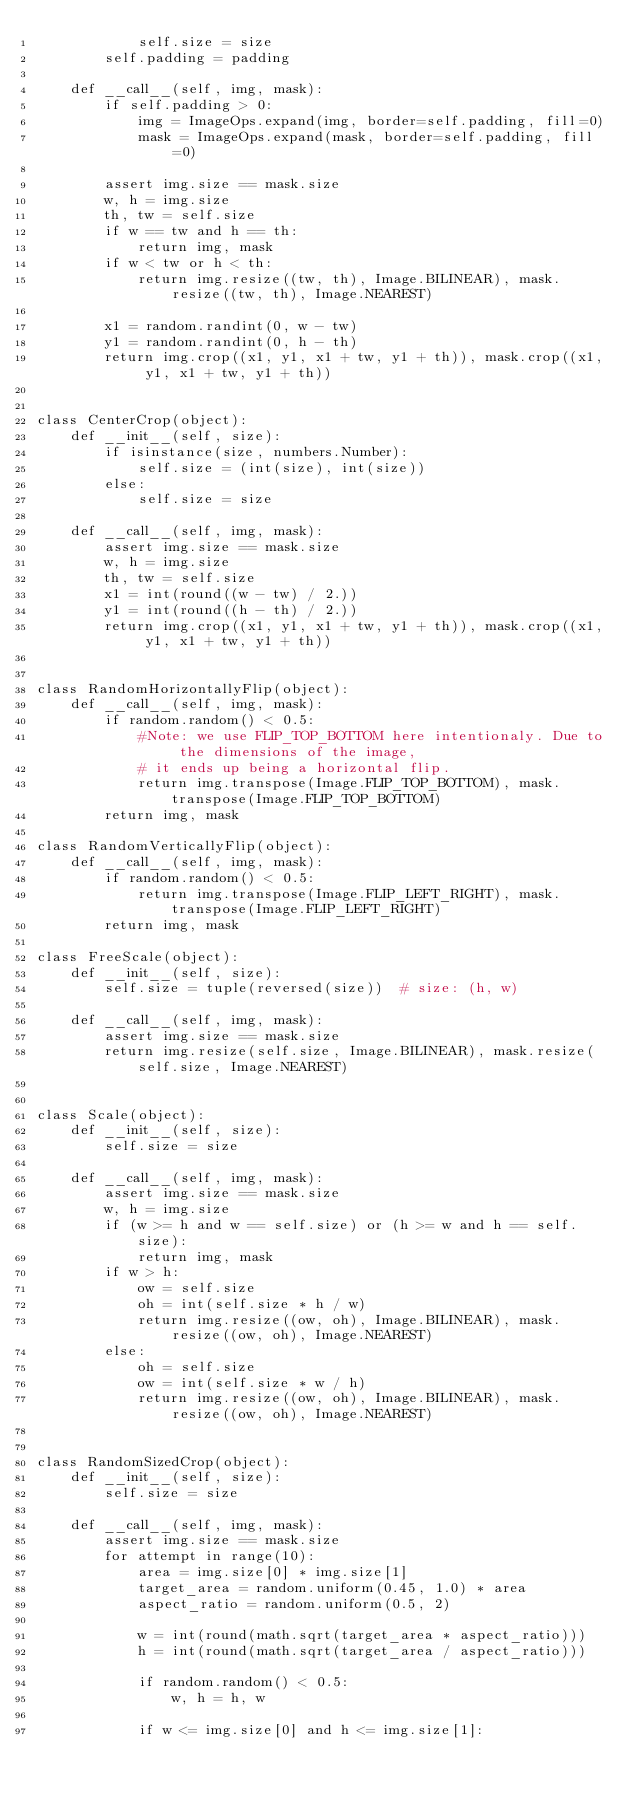Convert code to text. <code><loc_0><loc_0><loc_500><loc_500><_Python_>            self.size = size
        self.padding = padding

    def __call__(self, img, mask):
        if self.padding > 0:
            img = ImageOps.expand(img, border=self.padding, fill=0)
            mask = ImageOps.expand(mask, border=self.padding, fill=0)

        assert img.size == mask.size
        w, h = img.size
        th, tw = self.size
        if w == tw and h == th:
            return img, mask
        if w < tw or h < th:
            return img.resize((tw, th), Image.BILINEAR), mask.resize((tw, th), Image.NEAREST)

        x1 = random.randint(0, w - tw)
        y1 = random.randint(0, h - th)
        return img.crop((x1, y1, x1 + tw, y1 + th)), mask.crop((x1, y1, x1 + tw, y1 + th))


class CenterCrop(object):
    def __init__(self, size):
        if isinstance(size, numbers.Number):
            self.size = (int(size), int(size))
        else:
            self.size = size

    def __call__(self, img, mask):
        assert img.size == mask.size
        w, h = img.size
        th, tw = self.size
        x1 = int(round((w - tw) / 2.))
        y1 = int(round((h - th) / 2.))
        return img.crop((x1, y1, x1 + tw, y1 + th)), mask.crop((x1, y1, x1 + tw, y1 + th))


class RandomHorizontallyFlip(object):
    def __call__(self, img, mask):
        if random.random() < 0.5:
            #Note: we use FLIP_TOP_BOTTOM here intentionaly. Due to the dimensions of the image,
            # it ends up being a horizontal flip.
            return img.transpose(Image.FLIP_TOP_BOTTOM), mask.transpose(Image.FLIP_TOP_BOTTOM)
        return img, mask
    
class RandomVerticallyFlip(object):
    def __call__(self, img, mask):
        if random.random() < 0.5:
            return img.transpose(Image.FLIP_LEFT_RIGHT), mask.transpose(Image.FLIP_LEFT_RIGHT)
        return img, mask
   
class FreeScale(object):
    def __init__(self, size):
        self.size = tuple(reversed(size))  # size: (h, w)

    def __call__(self, img, mask):
        assert img.size == mask.size
        return img.resize(self.size, Image.BILINEAR), mask.resize(self.size, Image.NEAREST)


class Scale(object):
    def __init__(self, size):
        self.size = size

    def __call__(self, img, mask):
        assert img.size == mask.size
        w, h = img.size
        if (w >= h and w == self.size) or (h >= w and h == self.size):
            return img, mask
        if w > h:
            ow = self.size
            oh = int(self.size * h / w)
            return img.resize((ow, oh), Image.BILINEAR), mask.resize((ow, oh), Image.NEAREST)
        else:
            oh = self.size
            ow = int(self.size * w / h)
            return img.resize((ow, oh), Image.BILINEAR), mask.resize((ow, oh), Image.NEAREST)


class RandomSizedCrop(object):
    def __init__(self, size):
        self.size = size

    def __call__(self, img, mask):
        assert img.size == mask.size
        for attempt in range(10):
            area = img.size[0] * img.size[1]
            target_area = random.uniform(0.45, 1.0) * area
            aspect_ratio = random.uniform(0.5, 2)

            w = int(round(math.sqrt(target_area * aspect_ratio)))
            h = int(round(math.sqrt(target_area / aspect_ratio)))

            if random.random() < 0.5:
                w, h = h, w

            if w <= img.size[0] and h <= img.size[1]:</code> 